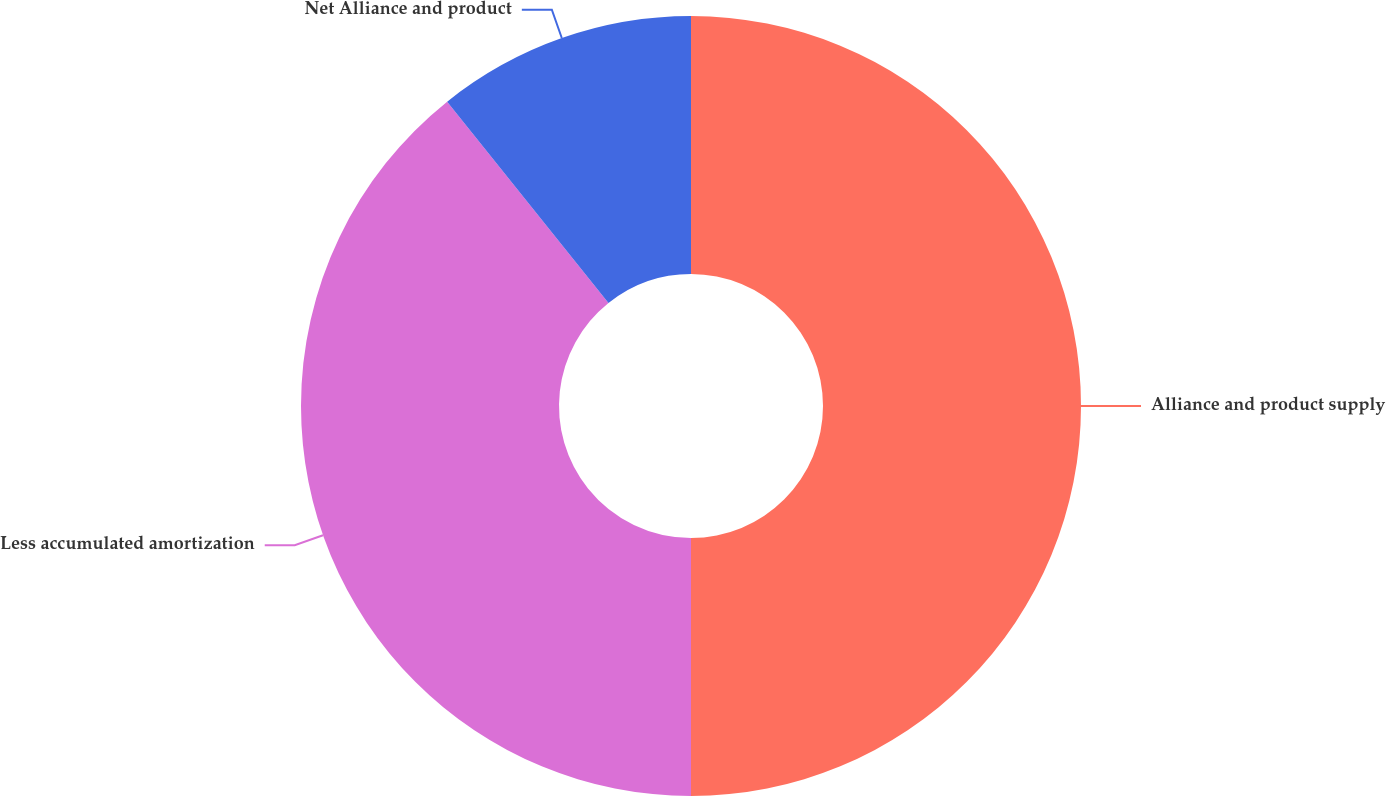<chart> <loc_0><loc_0><loc_500><loc_500><pie_chart><fcel>Alliance and product supply<fcel>Less accumulated amortization<fcel>Net Alliance and product<nl><fcel>50.0%<fcel>39.25%<fcel>10.75%<nl></chart> 